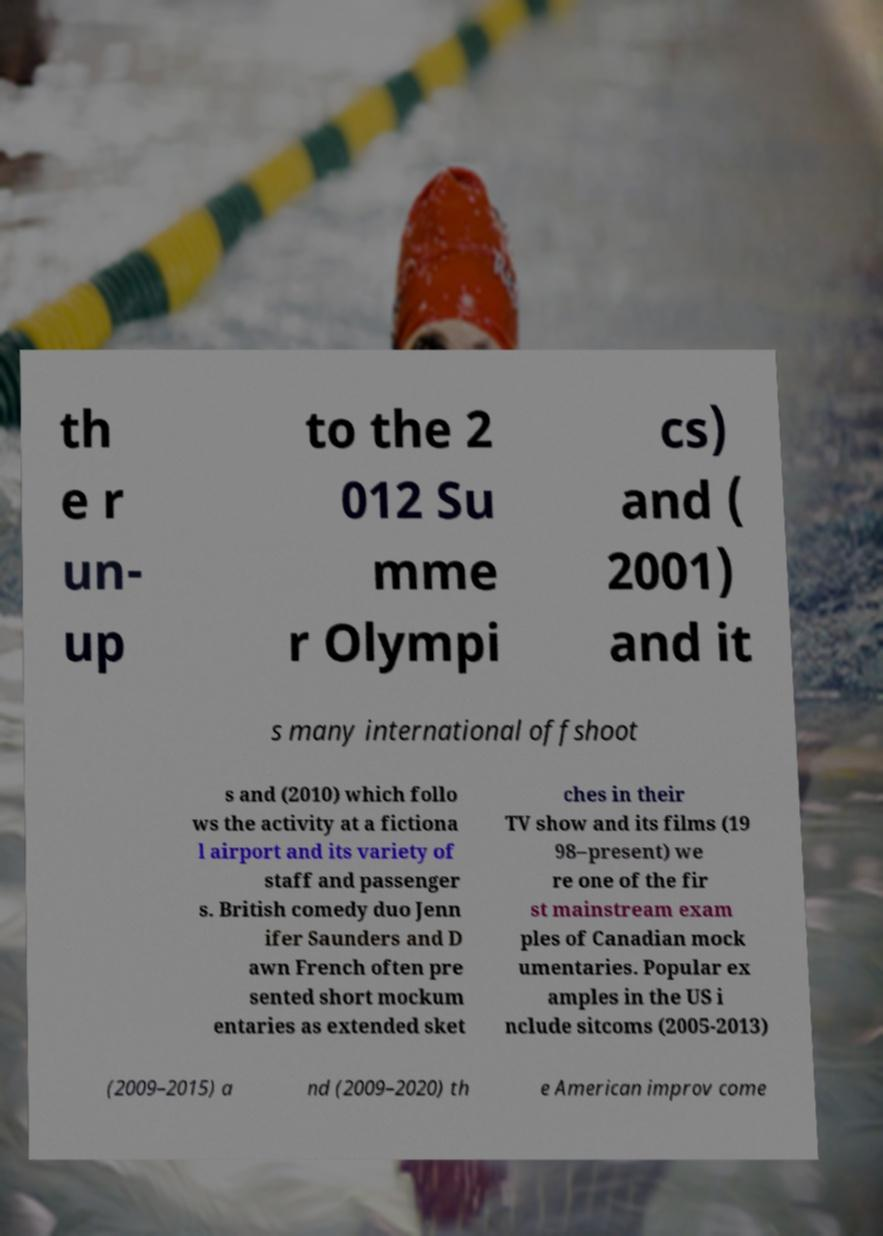I need the written content from this picture converted into text. Can you do that? th e r un- up to the 2 012 Su mme r Olympi cs) and ( 2001) and it s many international offshoot s and (2010) which follo ws the activity at a fictiona l airport and its variety of staff and passenger s. British comedy duo Jenn ifer Saunders and D awn French often pre sented short mockum entaries as extended sket ches in their TV show and its films (19 98–present) we re one of the fir st mainstream exam ples of Canadian mock umentaries. Popular ex amples in the US i nclude sitcoms (2005-2013) (2009–2015) a nd (2009–2020) th e American improv come 